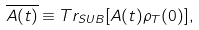Convert formula to latex. <formula><loc_0><loc_0><loc_500><loc_500>\overline { A ( t ) } \equiv T r _ { S U B } [ A ( t ) \rho _ { T } ( 0 ) ] ,</formula> 